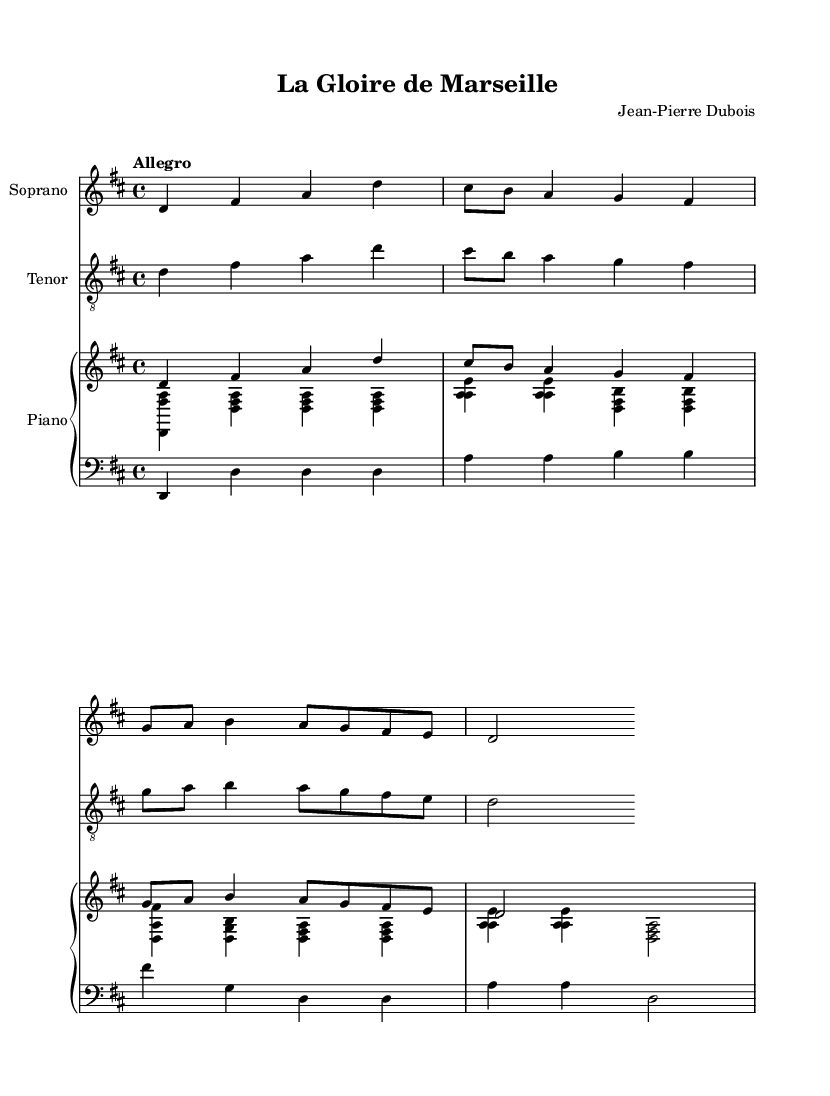What is the key signature of this music? The key signature is indicated at the beginning of the staff and shows two sharps. This corresponds to the key of D major.
Answer: D major What is the time signature of this music? The time signature is presented at the beginning of the staff indicating how many beats are in each measure and what type of note value gets the beat. In this case, it shows 4/4 time.
Answer: 4/4 What is the tempo marking of this music? The tempo marking is found above the staff, indicated as "Allegro," which suggests a quick and lively pace for the piece.
Answer: Allegro How many voices are there in the score? By examining the score, we can see there are three distinct staves: one for Soprano, one for Tenor, and a combined staff for Piano, indicating multiple voices.
Answer: Three What is the main theme's note sequence starting pitch? By looking at the main theme written in the relative pitch system, it starts on the note D in the second octave, indicating this is the first note of the theme.
Answer: D What is the lyric's subject in the verse? The lyrics reflect the pride of Marseille and its historical triumph in football, suggesting an emotional connection to the city and its victories. The repetitive mention of Marseille reinforces this theme.
Answer: Marseille Which instrument is notated in the bass clef? The bass clef staff specifies notes that are typically lower in pitch. In this score, the lower staff is clearly labeled with a bass clef, indicating that it is meant for piano accompaniment rather than for voices.
Answer: Piano 